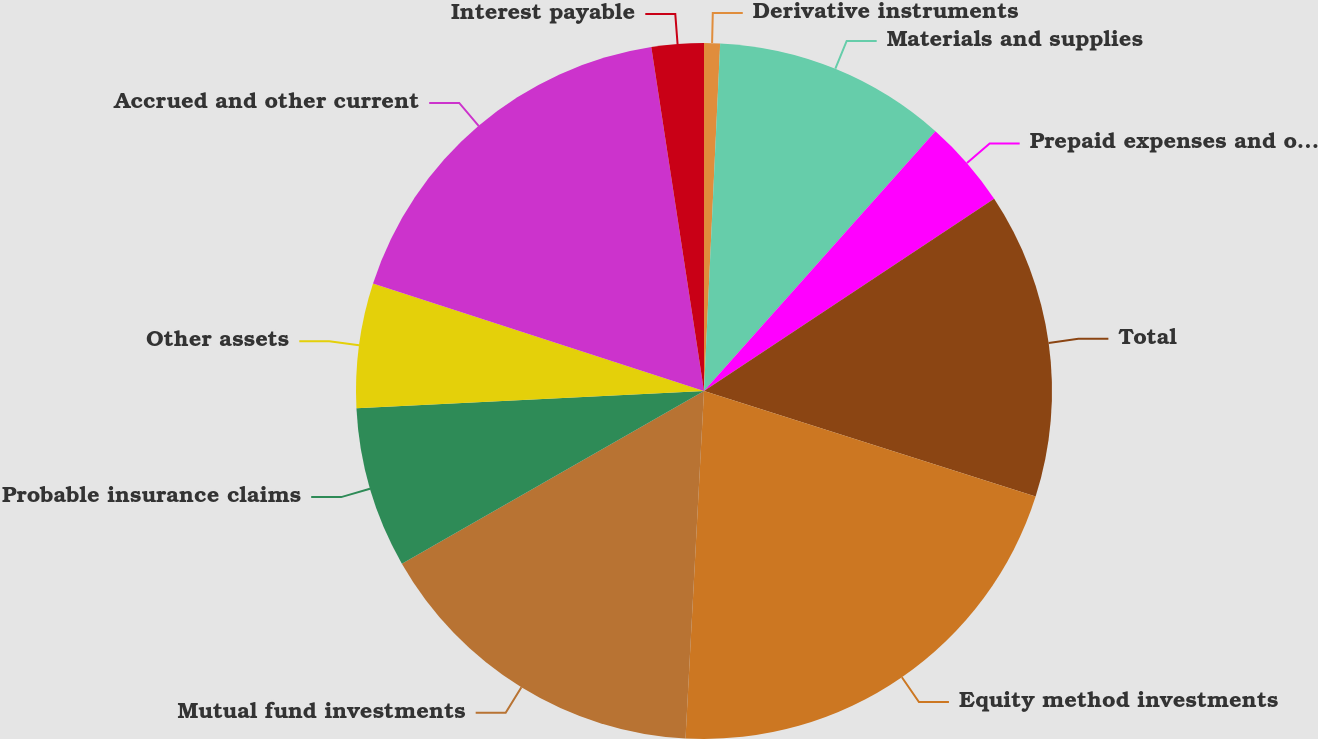<chart> <loc_0><loc_0><loc_500><loc_500><pie_chart><fcel>Derivative instruments<fcel>Materials and supplies<fcel>Prepaid expenses and other<fcel>Total<fcel>Equity method investments<fcel>Mutual fund investments<fcel>Probable insurance claims<fcel>Other assets<fcel>Accrued and other current<fcel>Interest payable<nl><fcel>0.74%<fcel>10.84%<fcel>4.11%<fcel>14.21%<fcel>20.94%<fcel>15.89%<fcel>7.47%<fcel>5.79%<fcel>17.58%<fcel>2.42%<nl></chart> 